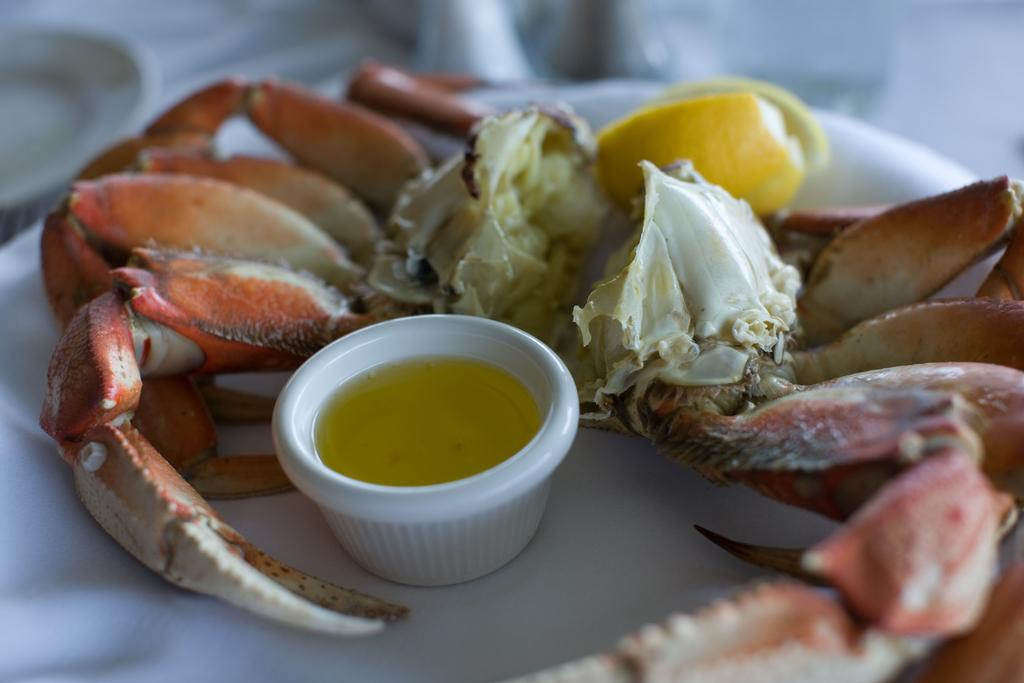What is the main piece of furniture in the image? There is a table in the image. What is placed on the table? There are food items and a cup with liquid on the table. Can you describe the location of the additional plate? There is another plate on the right side corner of the table. What type of account is being discussed at the table in the image? There is no discussion or account present in the image; it only shows a table with food items, a cup with liquid, and a plate. 